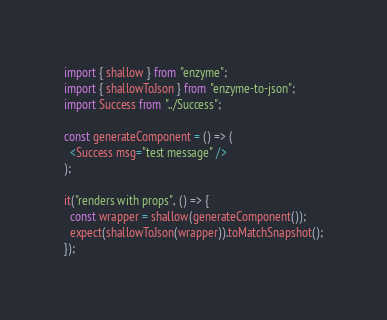<code> <loc_0><loc_0><loc_500><loc_500><_JavaScript_>import { shallow } from "enzyme";
import { shallowToJson } from "enzyme-to-json";
import Success from "../Success";

const generateComponent = () => (
  <Success msg="test message" />
);

it("renders with props", () => {
  const wrapper = shallow(generateComponent());
  expect(shallowToJson(wrapper)).toMatchSnapshot();
});
</code> 